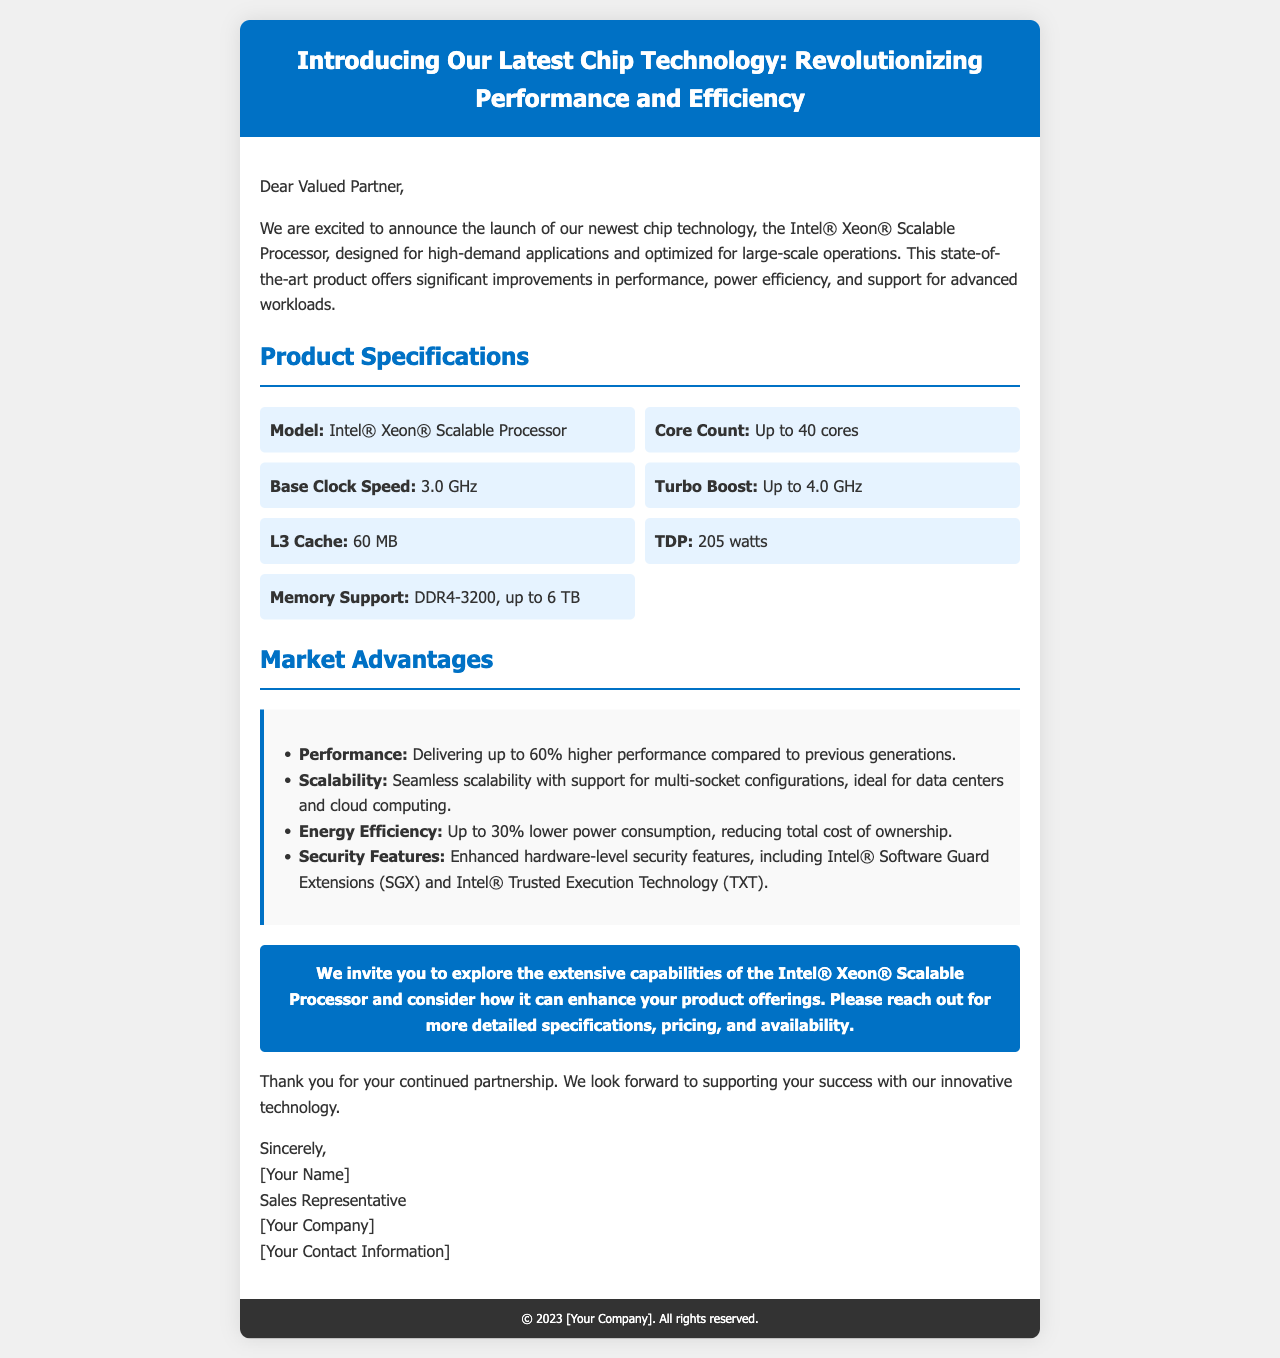what is the model of the new chip? The model of the new chip technology is specified in the document as the Intel® Xeon® Scalable Processor.
Answer: Intel® Xeon® Scalable Processor how many cores does the processor support? The maximum core count supported by the processor is mentioned in the specifications section of the document.
Answer: Up to 40 cores what is the base clock speed of the chip? The document indicates the base clock speed as one of the specifications listed.
Answer: 3.0 GHz what is the energy efficiency improvement compared to previous generations? The document states that the new chip technology offers an energy efficiency improvement in terms of power consumption.
Answer: Up to 30% lower what security feature is included in the new technology? The document lists specific security features provided by the chip which include Intel® Software Guard Extensions (SGX).
Answer: Intel® Software Guard Extensions (SGX) how does the performance of the new processor compare to previous generations? The document provides comparative performance information indicating the improvement over older models.
Answer: 60% higher performance what is the total memory support for the processor? The maximum memory support is specified in the product specifications section of the document.
Answer: Up to 6 TB what invitation is extended at the end of the document? The document invites readers to explore the capabilities of the new chip and provides information on further inquiries.
Answer: Explore the extensive capabilities of the Intel® Xeon® Scalable Processor who is the signatory of the email? The document contains a sign-off section that identifies the person concluding the communication.
Answer: [Your Name] 